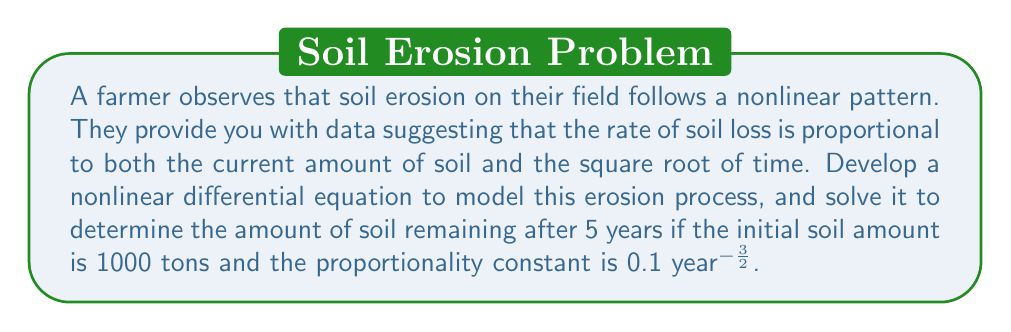Can you answer this question? 1) Let $S(t)$ represent the amount of soil at time $t$ in years. The rate of soil loss is given by $-\frac{dS}{dt}$.

2) Based on the farmer's observation, we can write the differential equation:

   $$-\frac{dS}{dt} = kS\sqrt{t}$$

   where $k$ is the proportionality constant.

3) Rearranging the equation:

   $$\frac{dS}{S} = -k\sqrt{t}dt$$

4) Integrating both sides:

   $$\int \frac{dS}{S} = -k\int \sqrt{t}dt$$

   $$\ln|S| = -\frac{2k}{3}t^{\frac{3}{2}} + C$$

5) Exponentiating both sides:

   $$S = e^{-\frac{2k}{3}t^{\frac{3}{2}} + C}$$

6) At $t=0$, $S=1000$, so:

   $$1000 = e^C$$
   $$C = \ln(1000)$$

7) Therefore, the general solution is:

   $$S(t) = 1000e^{-\frac{2k}{3}t^{\frac{3}{2}}}$$

8) Given $k=0.1$ and $t=5$, we can calculate the remaining soil:

   $$S(5) = 1000e^{-\frac{2(0.1)}{3}5^{\frac{3}{2}}}$$
   $$S(5) = 1000e^{-0.7453}$$
   $$S(5) \approx 474.65$$
Answer: 474.65 tons 